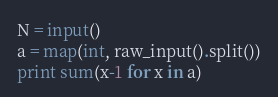Convert code to text. <code><loc_0><loc_0><loc_500><loc_500><_Python_>N = input()
a = map(int, raw_input().split())
print sum(x-1 for x in a)
</code> 